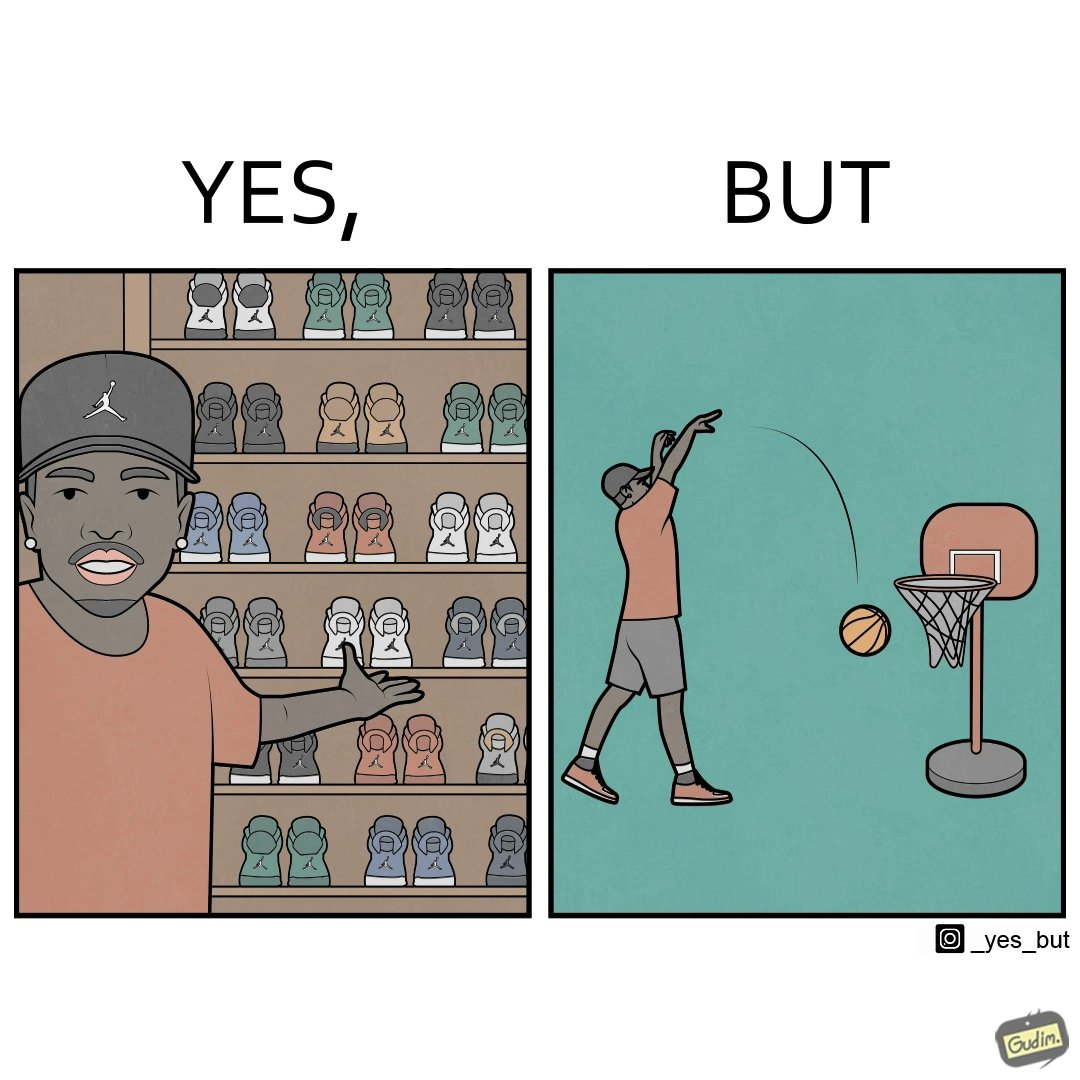Is there satirical content in this image? Yes, this image is satirical. 